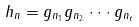<formula> <loc_0><loc_0><loc_500><loc_500>h _ { n } = g _ { n _ { 1 } } g _ { n _ { 2 } } \cdot \cdot \cdot g _ { n _ { t } }</formula> 